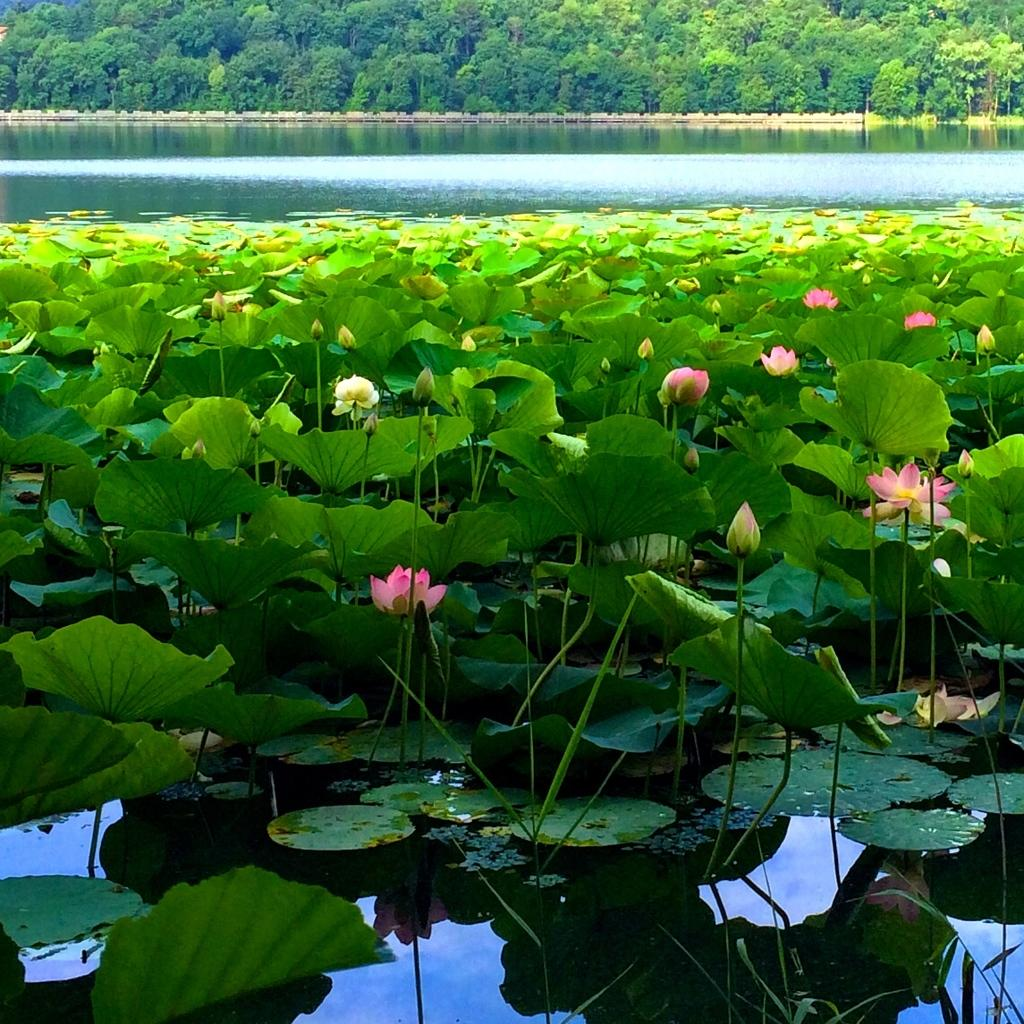What type of flora can be seen in the image? There are flowers and plants in the image. What is the primary element visible in the image? Water is visible in the image. What can be seen in the background of the image? There are trees in the background of the image. What type of stick can be seen on the stage in the image? There is no stick or stage present in the image. 